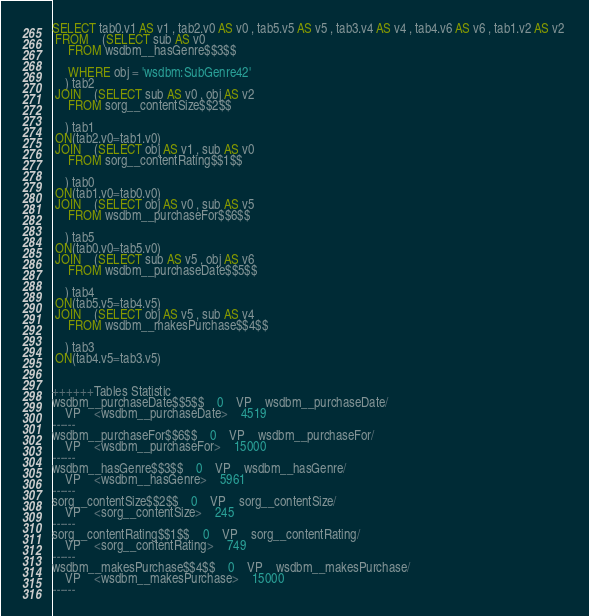Convert code to text. <code><loc_0><loc_0><loc_500><loc_500><_SQL_>SELECT tab0.v1 AS v1 , tab2.v0 AS v0 , tab5.v5 AS v5 , tab3.v4 AS v4 , tab4.v6 AS v6 , tab1.v2 AS v2 
 FROM    (SELECT sub AS v0 
	 FROM wsdbm__hasGenre$$3$$
	 
	 WHERE obj = 'wsdbm:SubGenre42'
	) tab2
 JOIN    (SELECT sub AS v0 , obj AS v2 
	 FROM sorg__contentSize$$2$$
	
	) tab1
 ON(tab2.v0=tab1.v0)
 JOIN    (SELECT obj AS v1 , sub AS v0 
	 FROM sorg__contentRating$$1$$
	
	) tab0
 ON(tab1.v0=tab0.v0)
 JOIN    (SELECT obj AS v0 , sub AS v5 
	 FROM wsdbm__purchaseFor$$6$$
	
	) tab5
 ON(tab0.v0=tab5.v0)
 JOIN    (SELECT sub AS v5 , obj AS v6 
	 FROM wsdbm__purchaseDate$$5$$
	
	) tab4
 ON(tab5.v5=tab4.v5)
 JOIN    (SELECT obj AS v5 , sub AS v4 
	 FROM wsdbm__makesPurchase$$4$$
	
	) tab3
 ON(tab4.v5=tab3.v5)


++++++Tables Statistic
wsdbm__purchaseDate$$5$$	0	VP	wsdbm__purchaseDate/
	VP	<wsdbm__purchaseDate>	4519
------
wsdbm__purchaseFor$$6$$	0	VP	wsdbm__purchaseFor/
	VP	<wsdbm__purchaseFor>	15000
------
wsdbm__hasGenre$$3$$	0	VP	wsdbm__hasGenre/
	VP	<wsdbm__hasGenre>	5961
------
sorg__contentSize$$2$$	0	VP	sorg__contentSize/
	VP	<sorg__contentSize>	245
------
sorg__contentRating$$1$$	0	VP	sorg__contentRating/
	VP	<sorg__contentRating>	749
------
wsdbm__makesPurchase$$4$$	0	VP	wsdbm__makesPurchase/
	VP	<wsdbm__makesPurchase>	15000
------
</code> 